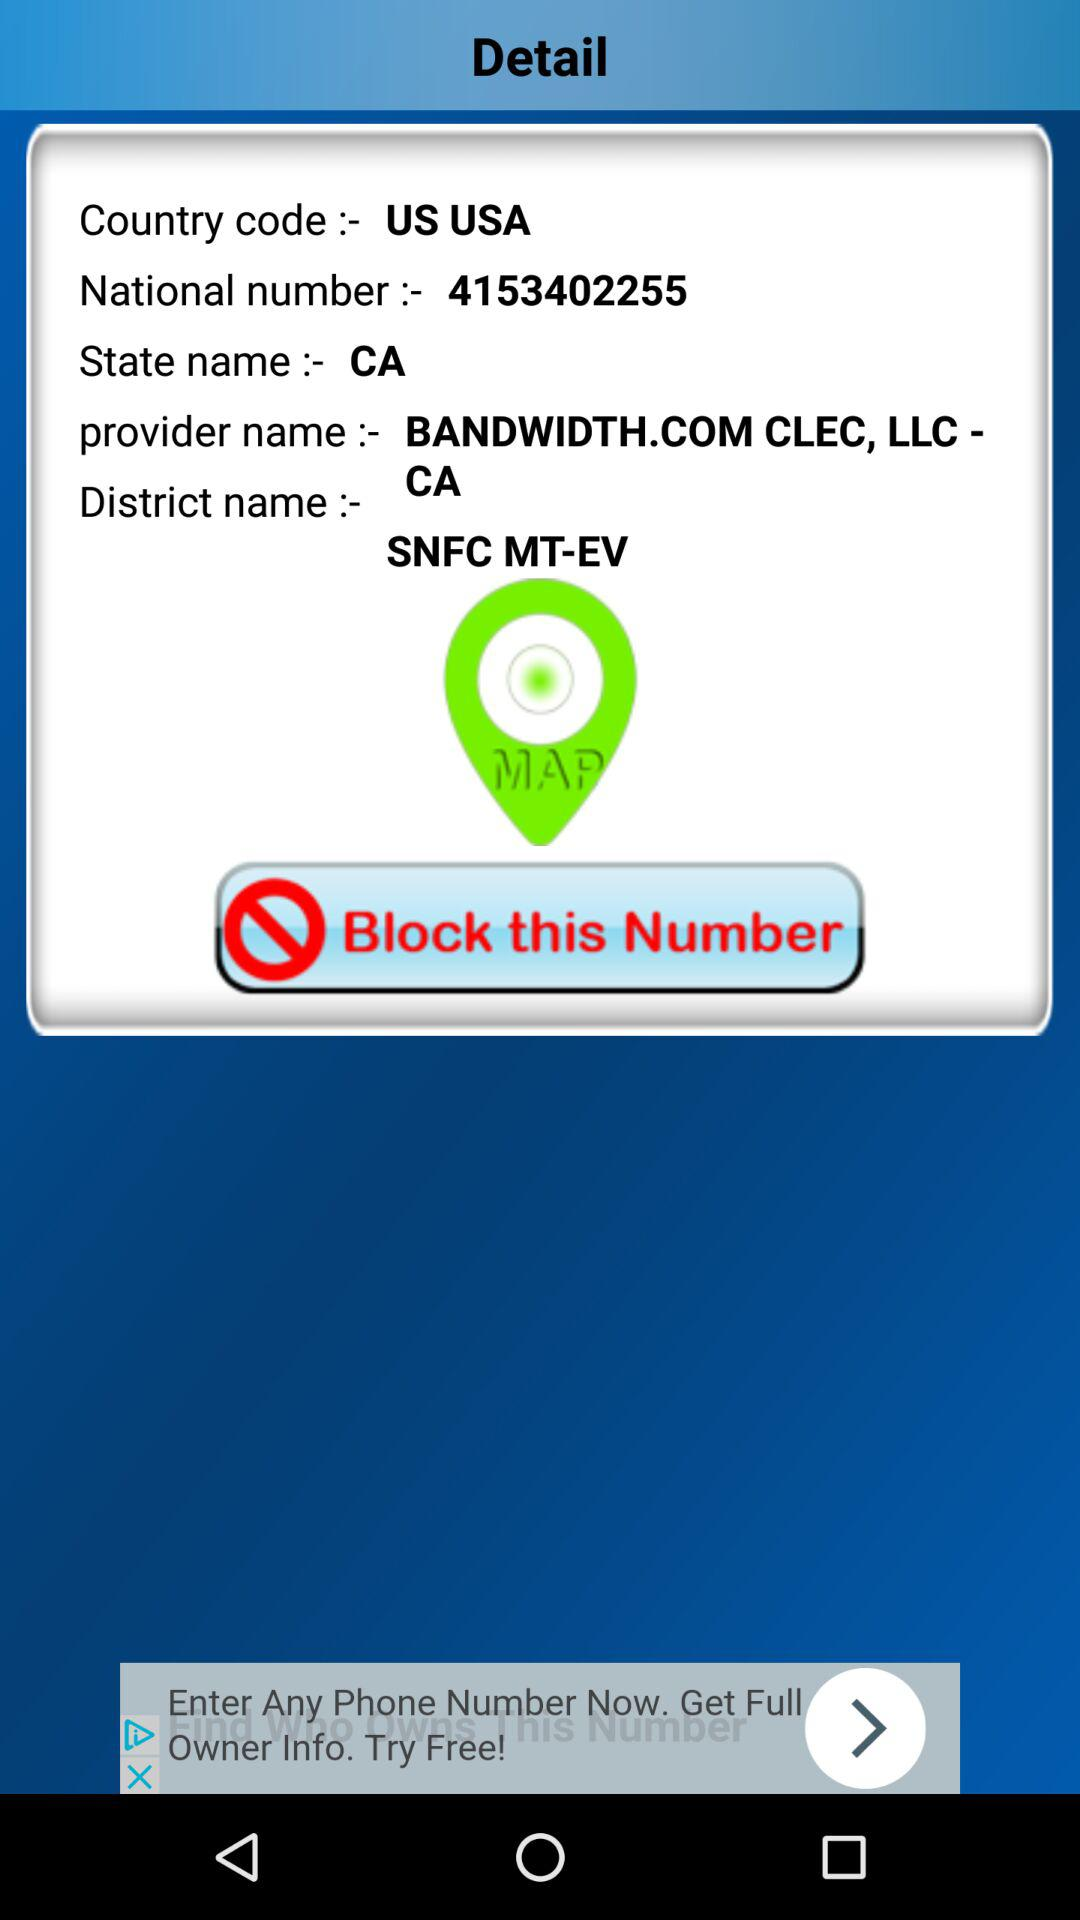What is the district name? The district name is SNFC MT-EV. 